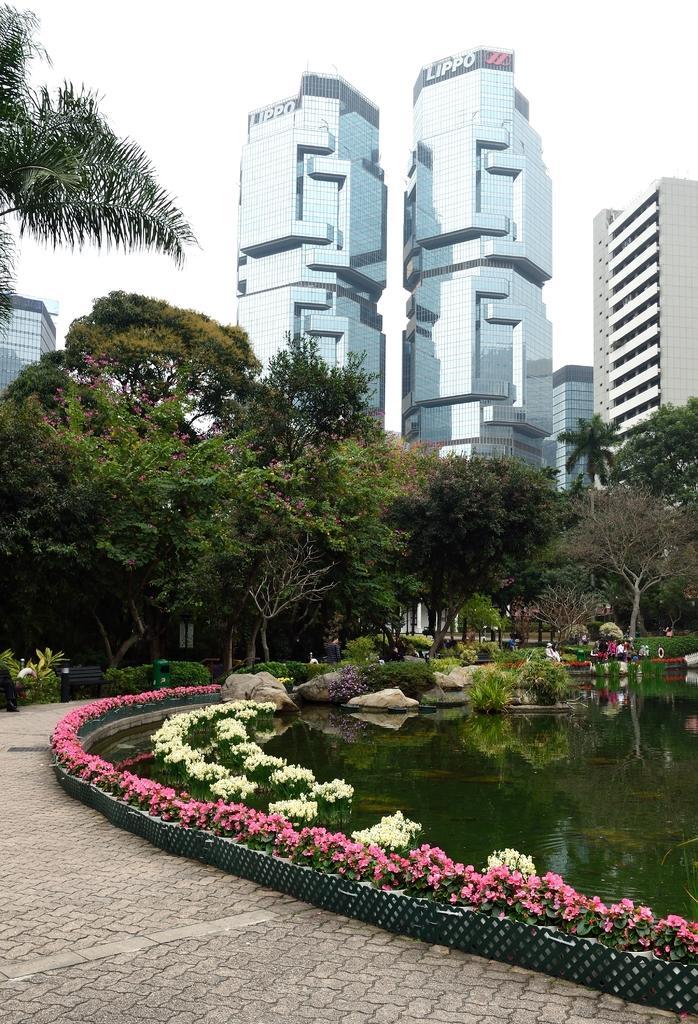Please provide a concise description of this image. In this image, we can see buildings, trees, bushes and some benches. At the bottom, there is water and we can see some stones and some flowers and there is a road. 